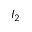Convert formula to latex. <formula><loc_0><loc_0><loc_500><loc_500>I _ { 2 }</formula> 